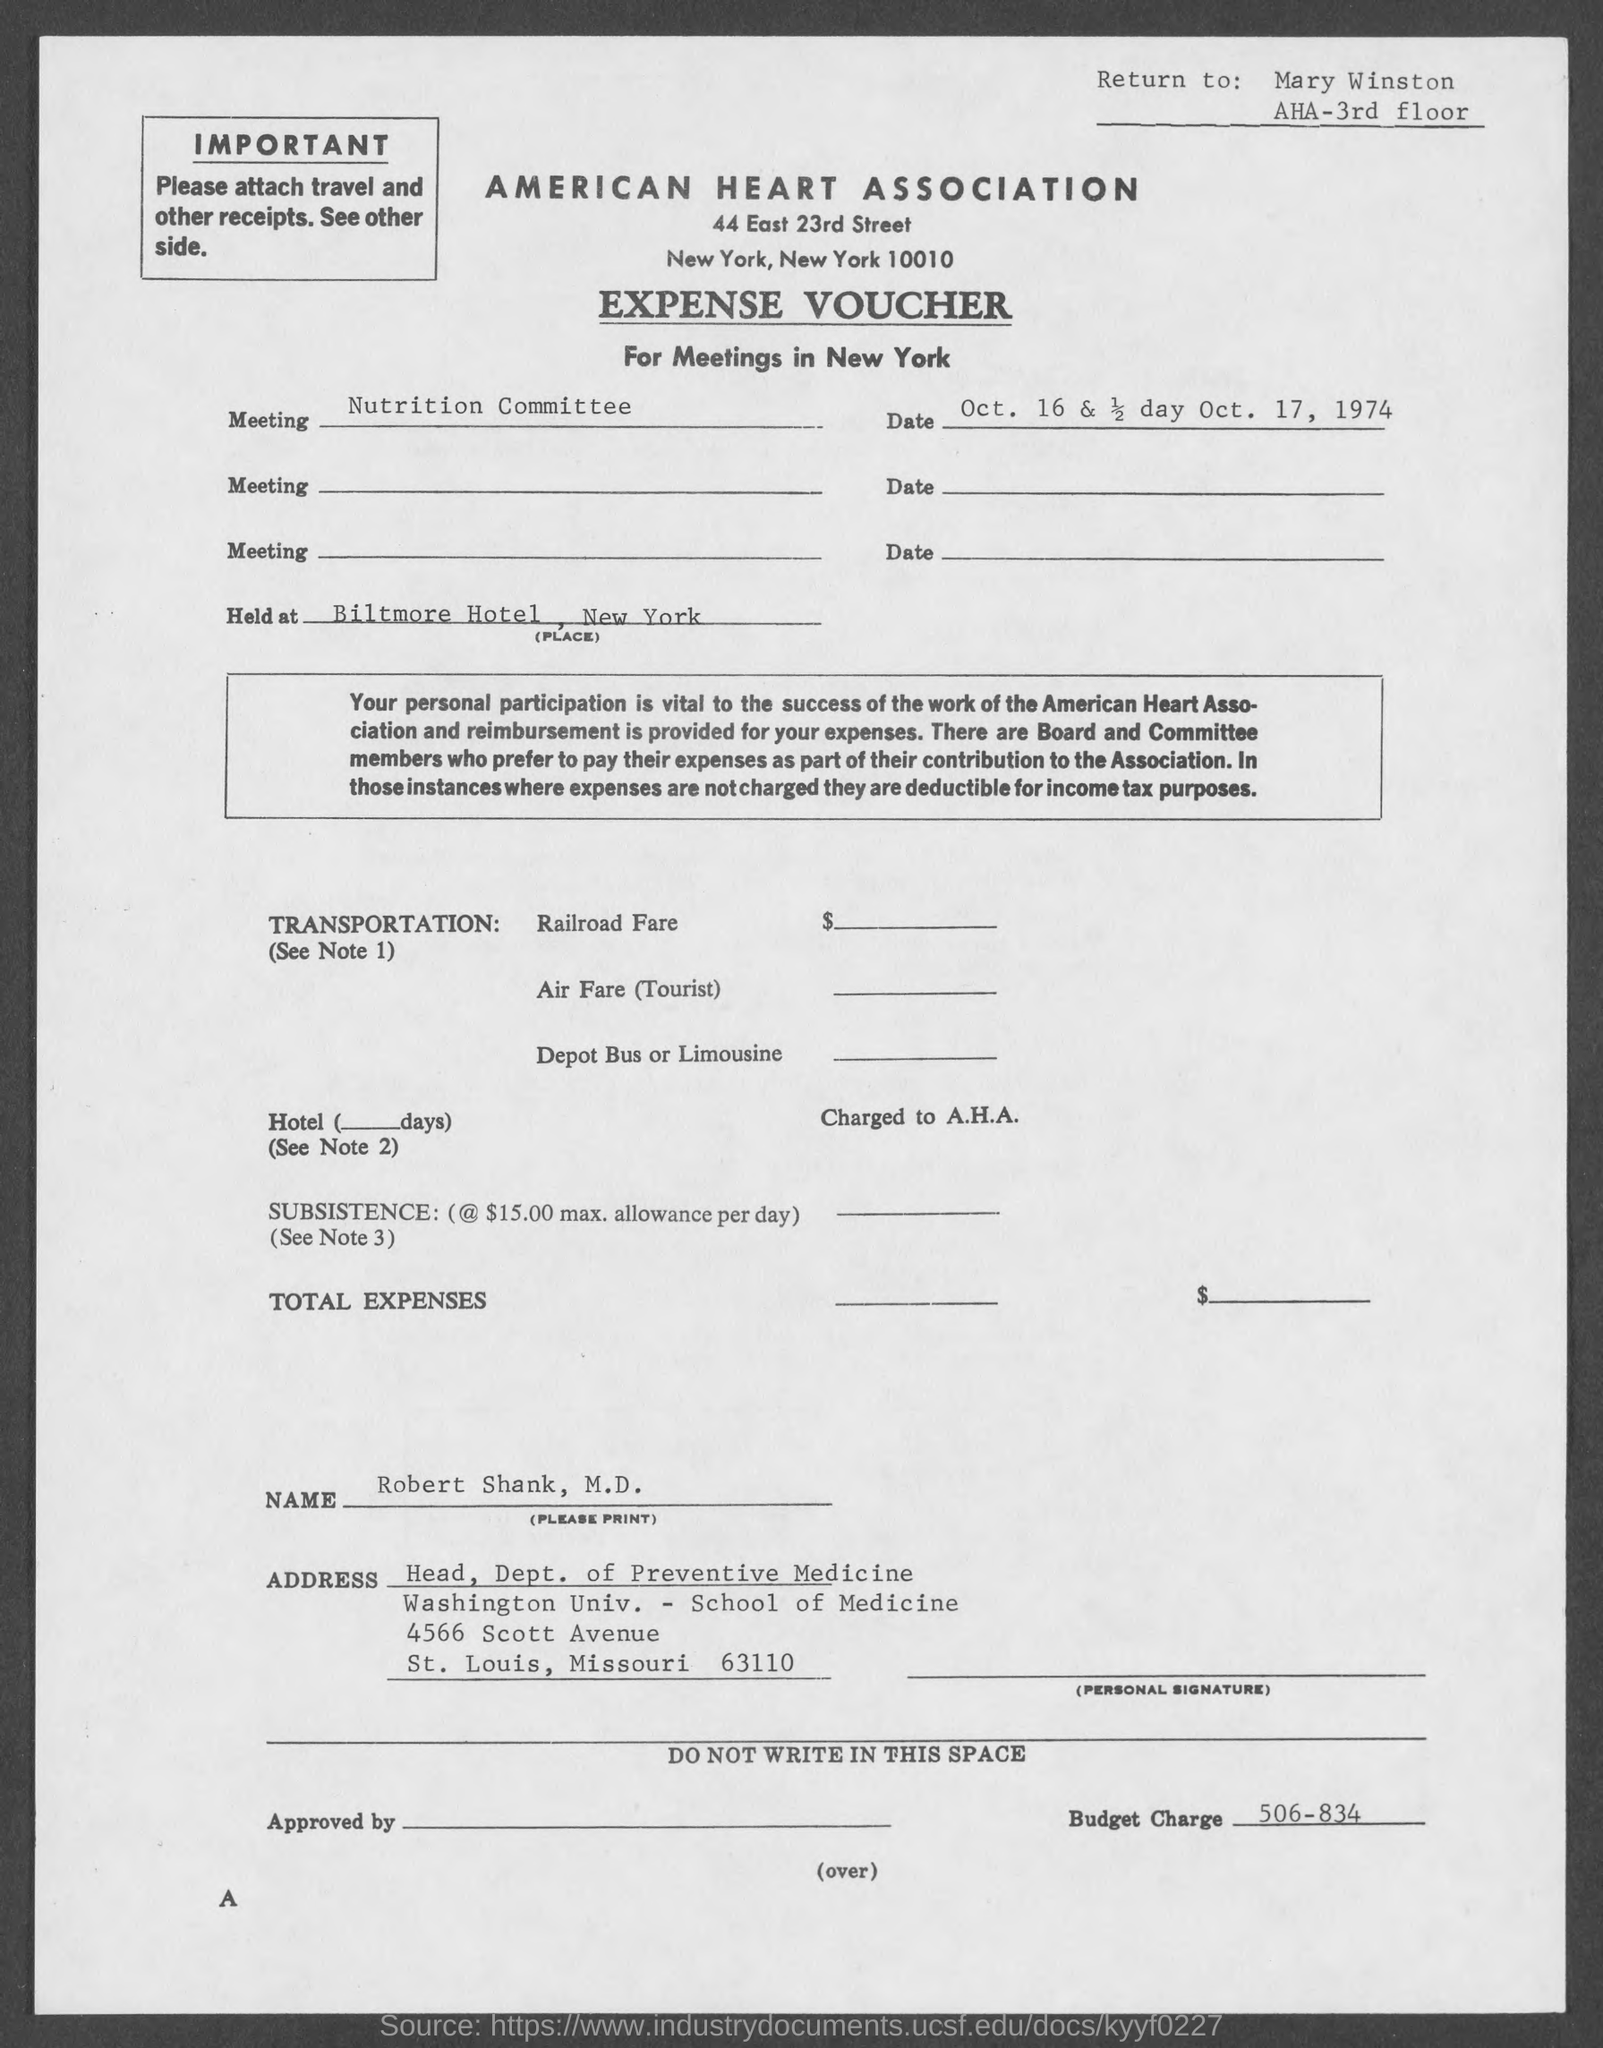Point out several critical features in this image. The Nutrition Committee is a meeting. The Biltmore Hotel in New York will be the location for the event. The budget charge is 506-834... 